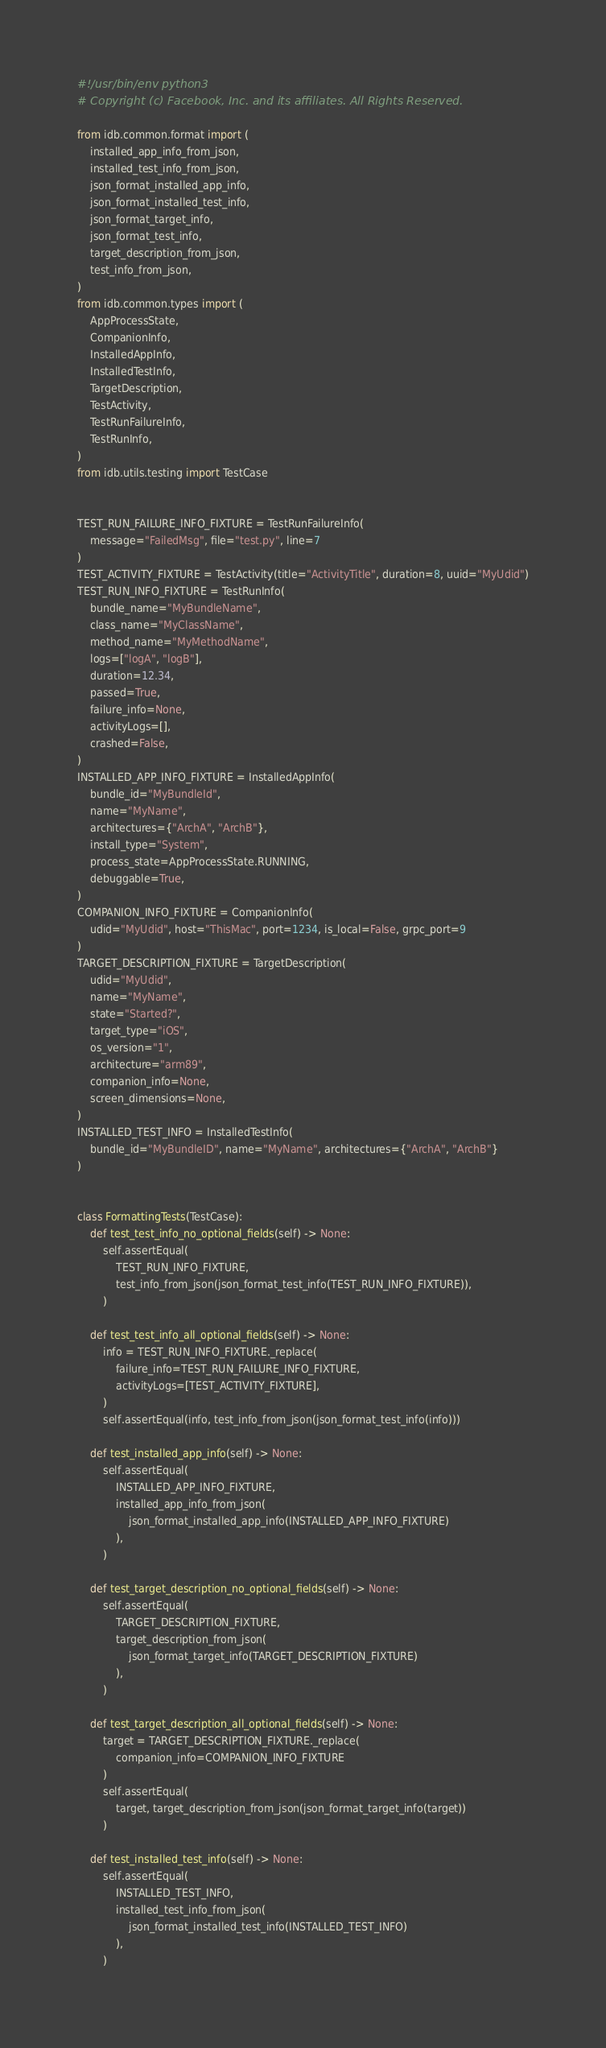Convert code to text. <code><loc_0><loc_0><loc_500><loc_500><_Python_>#!/usr/bin/env python3
# Copyright (c) Facebook, Inc. and its affiliates. All Rights Reserved.

from idb.common.format import (
    installed_app_info_from_json,
    installed_test_info_from_json,
    json_format_installed_app_info,
    json_format_installed_test_info,
    json_format_target_info,
    json_format_test_info,
    target_description_from_json,
    test_info_from_json,
)
from idb.common.types import (
    AppProcessState,
    CompanionInfo,
    InstalledAppInfo,
    InstalledTestInfo,
    TargetDescription,
    TestActivity,
    TestRunFailureInfo,
    TestRunInfo,
)
from idb.utils.testing import TestCase


TEST_RUN_FAILURE_INFO_FIXTURE = TestRunFailureInfo(
    message="FailedMsg", file="test.py", line=7
)
TEST_ACTIVITY_FIXTURE = TestActivity(title="ActivityTitle", duration=8, uuid="MyUdid")
TEST_RUN_INFO_FIXTURE = TestRunInfo(
    bundle_name="MyBundleName",
    class_name="MyClassName",
    method_name="MyMethodName",
    logs=["logA", "logB"],
    duration=12.34,
    passed=True,
    failure_info=None,
    activityLogs=[],
    crashed=False,
)
INSTALLED_APP_INFO_FIXTURE = InstalledAppInfo(
    bundle_id="MyBundleId",
    name="MyName",
    architectures={"ArchA", "ArchB"},
    install_type="System",
    process_state=AppProcessState.RUNNING,
    debuggable=True,
)
COMPANION_INFO_FIXTURE = CompanionInfo(
    udid="MyUdid", host="ThisMac", port=1234, is_local=False, grpc_port=9
)
TARGET_DESCRIPTION_FIXTURE = TargetDescription(
    udid="MyUdid",
    name="MyName",
    state="Started?",
    target_type="iOS",
    os_version="1",
    architecture="arm89",
    companion_info=None,
    screen_dimensions=None,
)
INSTALLED_TEST_INFO = InstalledTestInfo(
    bundle_id="MyBundleID", name="MyName", architectures={"ArchA", "ArchB"}
)


class FormattingTests(TestCase):
    def test_test_info_no_optional_fields(self) -> None:
        self.assertEqual(
            TEST_RUN_INFO_FIXTURE,
            test_info_from_json(json_format_test_info(TEST_RUN_INFO_FIXTURE)),
        )

    def test_test_info_all_optional_fields(self) -> None:
        info = TEST_RUN_INFO_FIXTURE._replace(
            failure_info=TEST_RUN_FAILURE_INFO_FIXTURE,
            activityLogs=[TEST_ACTIVITY_FIXTURE],
        )
        self.assertEqual(info, test_info_from_json(json_format_test_info(info)))

    def test_installed_app_info(self) -> None:
        self.assertEqual(
            INSTALLED_APP_INFO_FIXTURE,
            installed_app_info_from_json(
                json_format_installed_app_info(INSTALLED_APP_INFO_FIXTURE)
            ),
        )

    def test_target_description_no_optional_fields(self) -> None:
        self.assertEqual(
            TARGET_DESCRIPTION_FIXTURE,
            target_description_from_json(
                json_format_target_info(TARGET_DESCRIPTION_FIXTURE)
            ),
        )

    def test_target_description_all_optional_fields(self) -> None:
        target = TARGET_DESCRIPTION_FIXTURE._replace(
            companion_info=COMPANION_INFO_FIXTURE
        )
        self.assertEqual(
            target, target_description_from_json(json_format_target_info(target))
        )

    def test_installed_test_info(self) -> None:
        self.assertEqual(
            INSTALLED_TEST_INFO,
            installed_test_info_from_json(
                json_format_installed_test_info(INSTALLED_TEST_INFO)
            ),
        )
</code> 